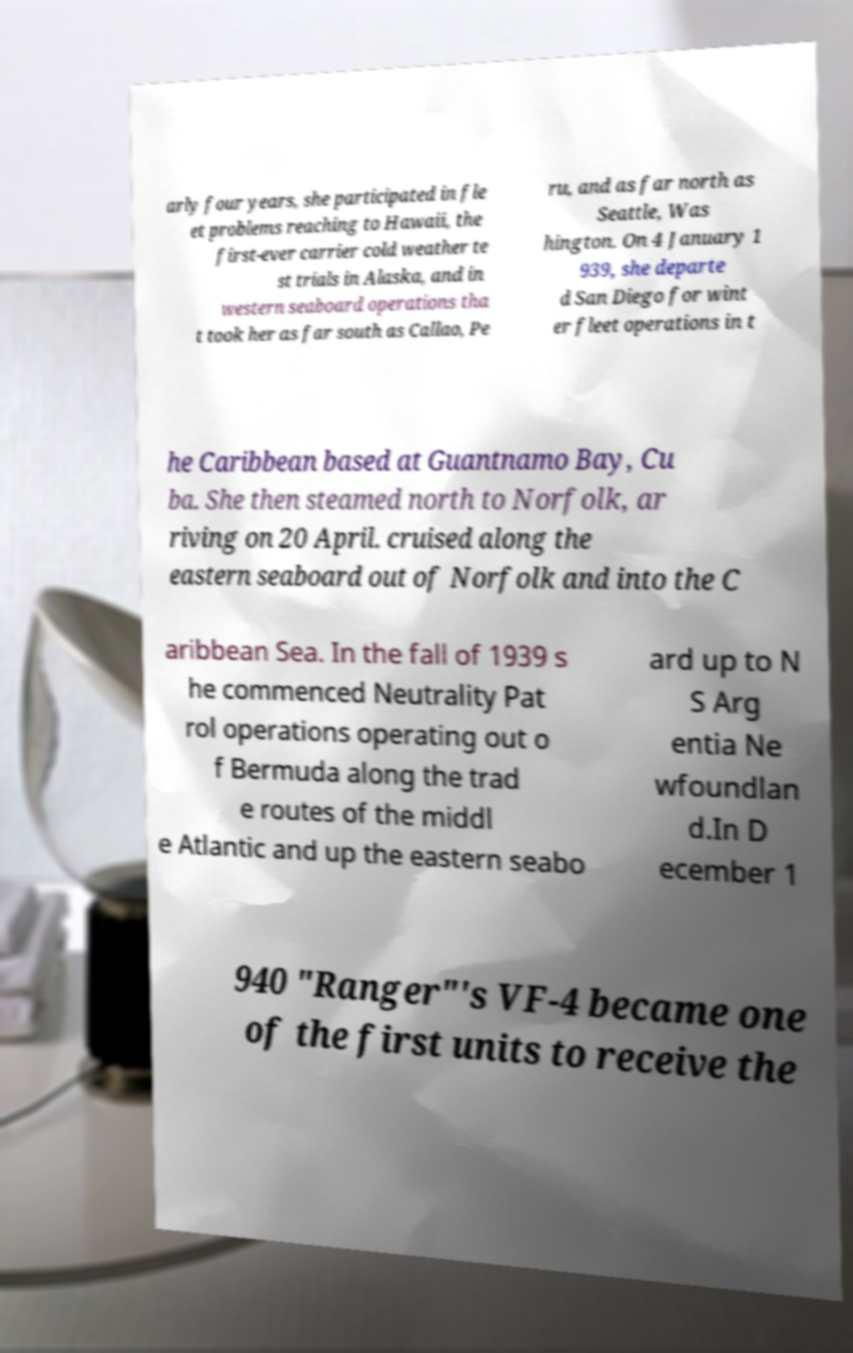Please identify and transcribe the text found in this image. arly four years, she participated in fle et problems reaching to Hawaii, the first-ever carrier cold weather te st trials in Alaska, and in western seaboard operations tha t took her as far south as Callao, Pe ru, and as far north as Seattle, Was hington. On 4 January 1 939, she departe d San Diego for wint er fleet operations in t he Caribbean based at Guantnamo Bay, Cu ba. She then steamed north to Norfolk, ar riving on 20 April. cruised along the eastern seaboard out of Norfolk and into the C aribbean Sea. In the fall of 1939 s he commenced Neutrality Pat rol operations operating out o f Bermuda along the trad e routes of the middl e Atlantic and up the eastern seabo ard up to N S Arg entia Ne wfoundlan d.In D ecember 1 940 "Ranger"'s VF-4 became one of the first units to receive the 